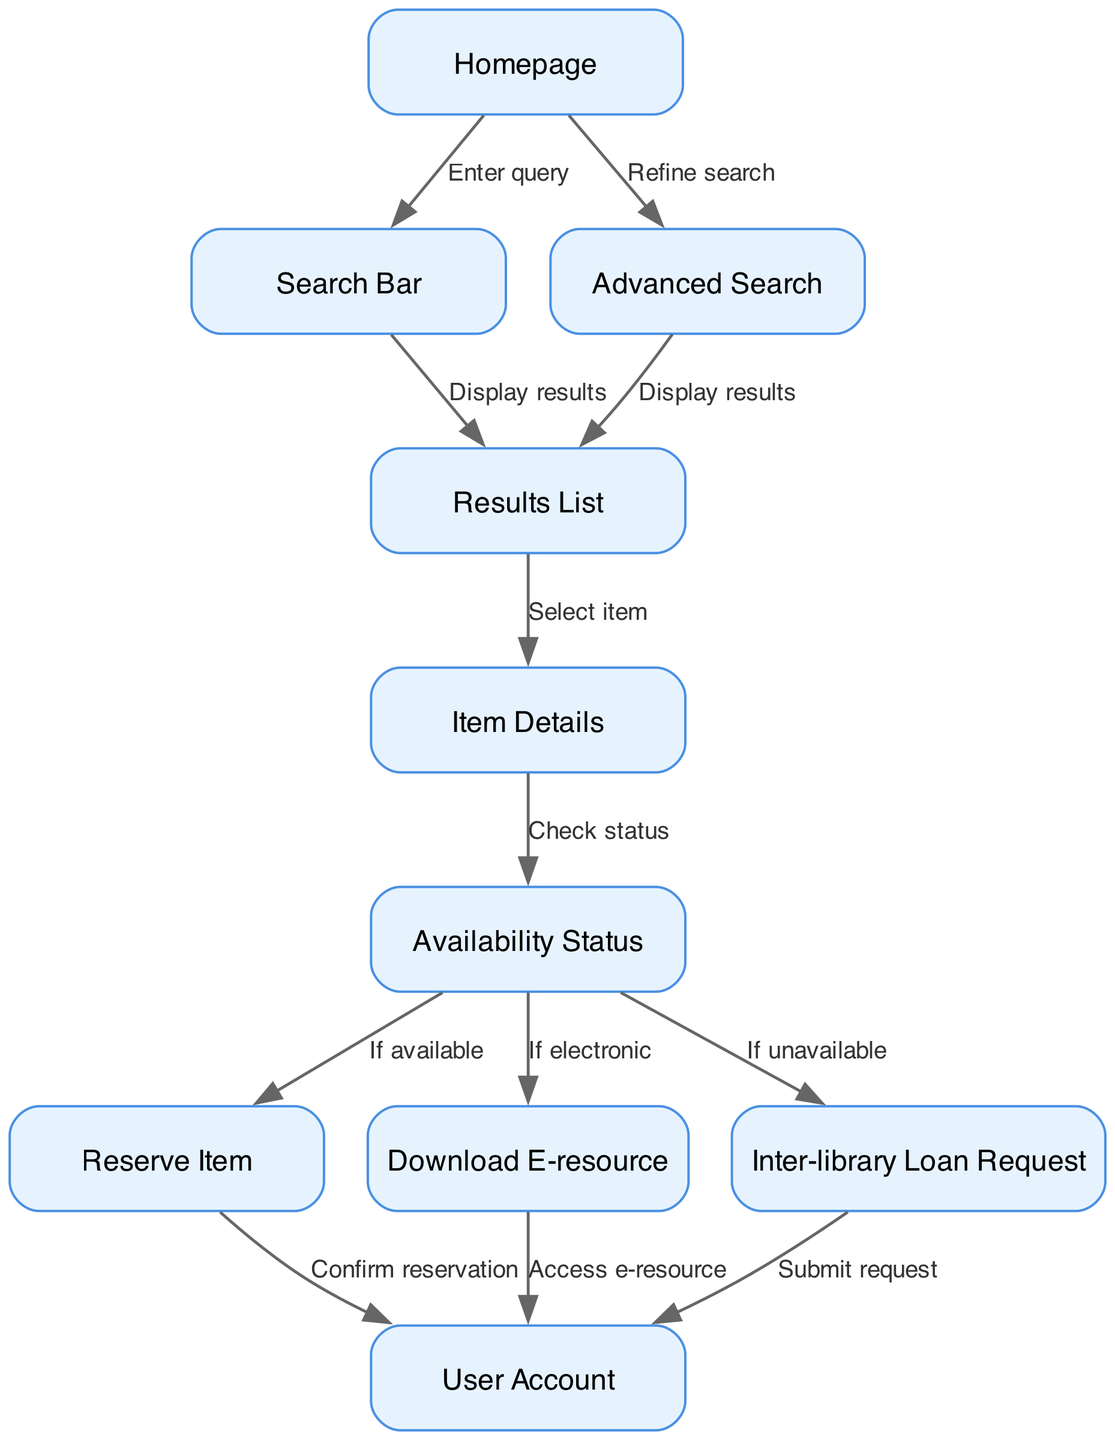What is the starting point of the user journey? The user journey begins at the "Homepage", as it is the first node in the directed graph.
Answer: Homepage How many nodes are there in the diagram? By counting all unique locations in the diagram, we find there are 10 nodes representing various stages in the user journey.
Answer: 10 What is the action taken to move from the "Homepage" to the "Results List"? The action displayed for this transition is "Display results", as both "Search Bar" and "Advanced Search" lead to the same "Results List" node.
Answer: Display results What happens after checking the "Availability Status" if it is available? If the item is available, the user can then choose to "Reserve Item", signifying a valid next step from "Availability Status".
Answer: Reserve Item How many different paths lead to the "User Account"? There are three paths leading to "User Account": from "Reserve Item", "Download E-resource", and "Inter-library Loan Request", indicating multiple options for users to reach their account.
Answer: 3 What is required for a user to proceed from "Availability Status" to "Download E-resource"? The user can proceed to "Download E-resource" if the item is "If electronic", indicating a specific condition that must be met.
Answer: If electronic Where does the action "Submit request" lead the user? The action "Submit request" leads the user to the "User Account", as it is the final outcome of the inter-library loan request process.
Answer: User Account What nodes connect directly to the "Results List"? The nodes that connect to "Results List" are "Search Bar" and "Advanced Search", as both paths lead to the same results.
Answer: Search Bar, Advanced Search What signifies the user selecting an item in the "Results List"? The action that signifies this selection is labeled "Select item", which leads the user to "Item Details" for more information about the chosen resource.
Answer: Select item 